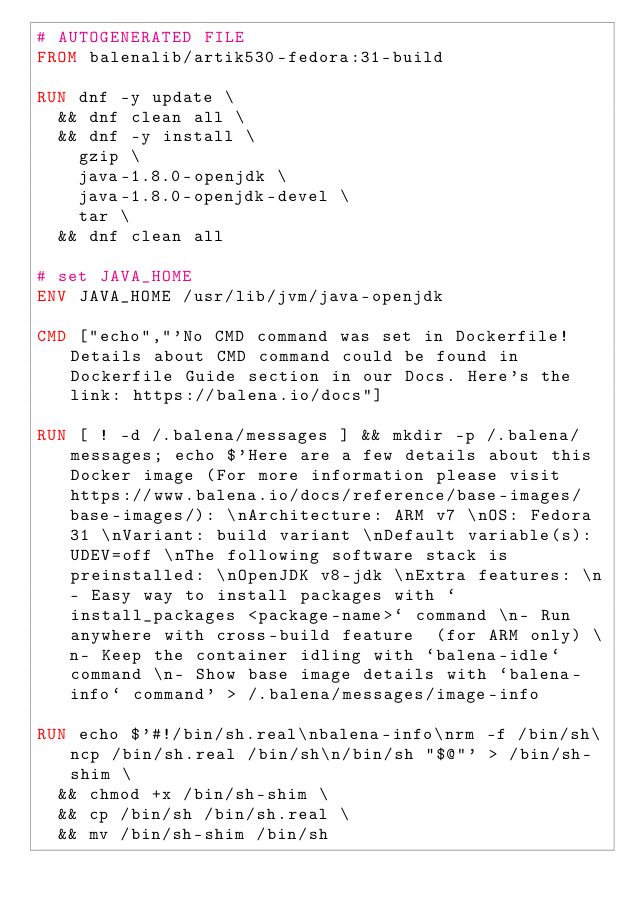<code> <loc_0><loc_0><loc_500><loc_500><_Dockerfile_># AUTOGENERATED FILE
FROM balenalib/artik530-fedora:31-build

RUN dnf -y update \
	&& dnf clean all \
	&& dnf -y install \
		gzip \
		java-1.8.0-openjdk \
		java-1.8.0-openjdk-devel \
		tar \
	&& dnf clean all

# set JAVA_HOME
ENV JAVA_HOME /usr/lib/jvm/java-openjdk

CMD ["echo","'No CMD command was set in Dockerfile! Details about CMD command could be found in Dockerfile Guide section in our Docs. Here's the link: https://balena.io/docs"]

RUN [ ! -d /.balena/messages ] && mkdir -p /.balena/messages; echo $'Here are a few details about this Docker image (For more information please visit https://www.balena.io/docs/reference/base-images/base-images/): \nArchitecture: ARM v7 \nOS: Fedora 31 \nVariant: build variant \nDefault variable(s): UDEV=off \nThe following software stack is preinstalled: \nOpenJDK v8-jdk \nExtra features: \n- Easy way to install packages with `install_packages <package-name>` command \n- Run anywhere with cross-build feature  (for ARM only) \n- Keep the container idling with `balena-idle` command \n- Show base image details with `balena-info` command' > /.balena/messages/image-info

RUN echo $'#!/bin/sh.real\nbalena-info\nrm -f /bin/sh\ncp /bin/sh.real /bin/sh\n/bin/sh "$@"' > /bin/sh-shim \
	&& chmod +x /bin/sh-shim \
	&& cp /bin/sh /bin/sh.real \
	&& mv /bin/sh-shim /bin/sh</code> 